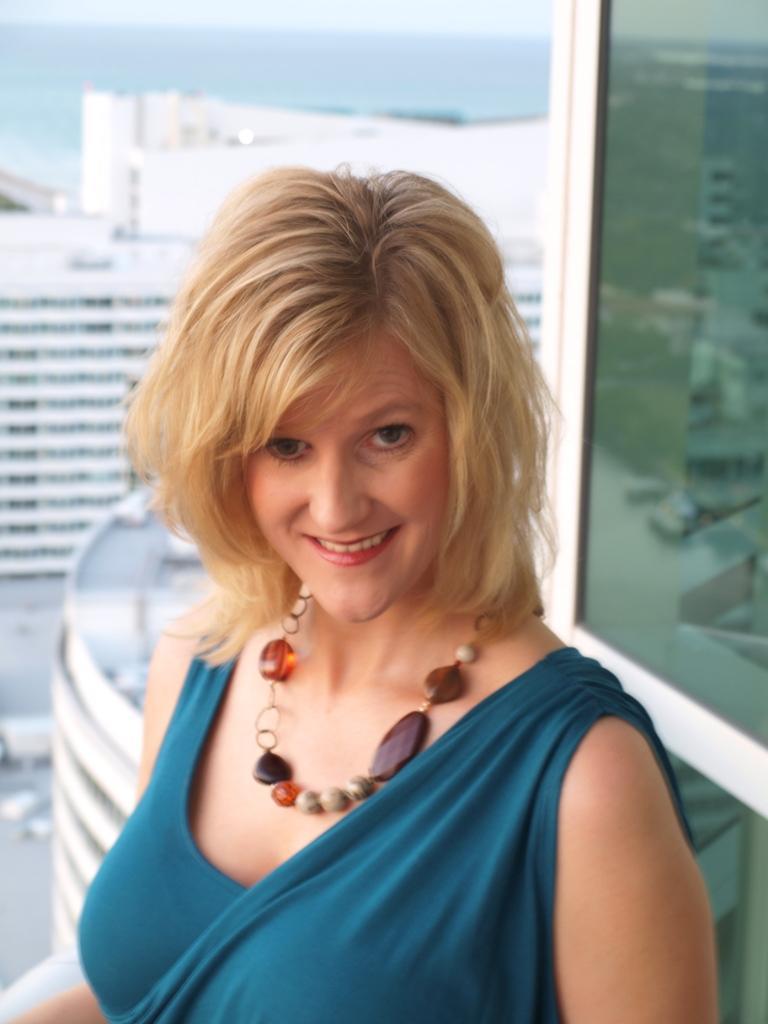Please provide a concise description of this image. In the center of the image we can see one woman is smiling and she is in a different costume. In the background, we can see buildings, glass and a few other objects. 